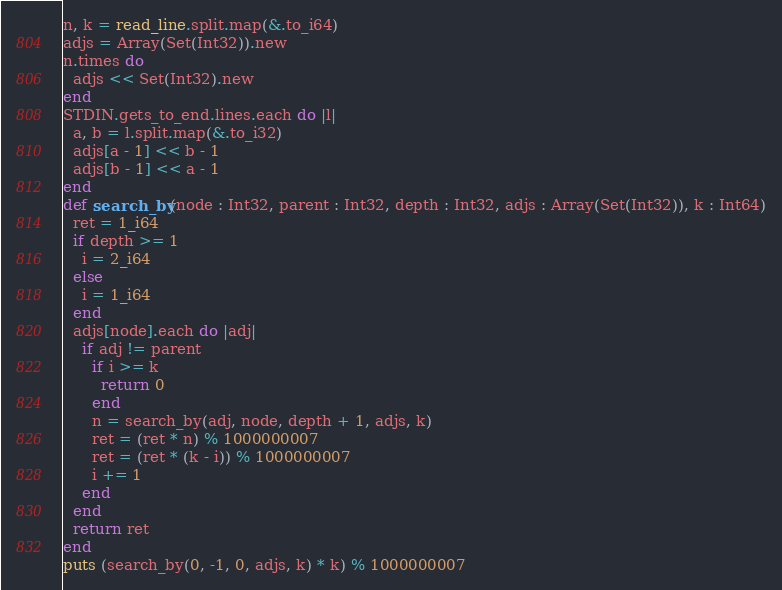<code> <loc_0><loc_0><loc_500><loc_500><_Crystal_>n, k = read_line.split.map(&.to_i64)
adjs = Array(Set(Int32)).new
n.times do
  adjs << Set(Int32).new
end
STDIN.gets_to_end.lines.each do |l|
  a, b = l.split.map(&.to_i32)
  adjs[a - 1] << b - 1
  adjs[b - 1] << a - 1
end
def search_by(node : Int32, parent : Int32, depth : Int32, adjs : Array(Set(Int32)), k : Int64)
  ret = 1_i64
  if depth >= 1
    i = 2_i64
  else
    i = 1_i64
  end
  adjs[node].each do |adj|
    if adj != parent
      if i >= k
        return 0
      end
      n = search_by(adj, node, depth + 1, adjs, k)
      ret = (ret * n) % 1000000007
      ret = (ret * (k - i)) % 1000000007
      i += 1
    end
  end
  return ret
end
puts (search_by(0, -1, 0, adjs, k) * k) % 1000000007
</code> 